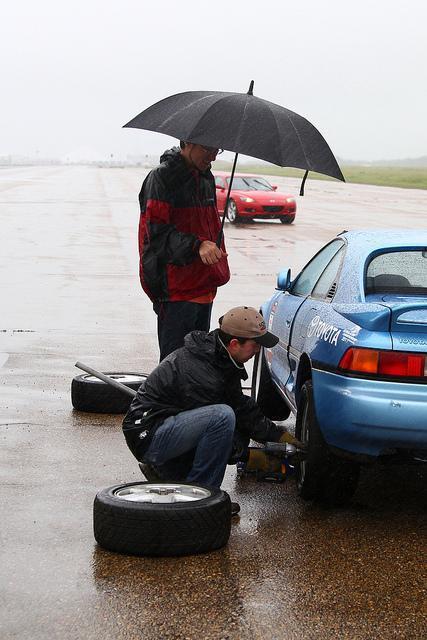How many people are there?
Give a very brief answer. 2. How many cars are in the photo?
Give a very brief answer. 2. How many bottles are on the table?
Give a very brief answer. 0. 